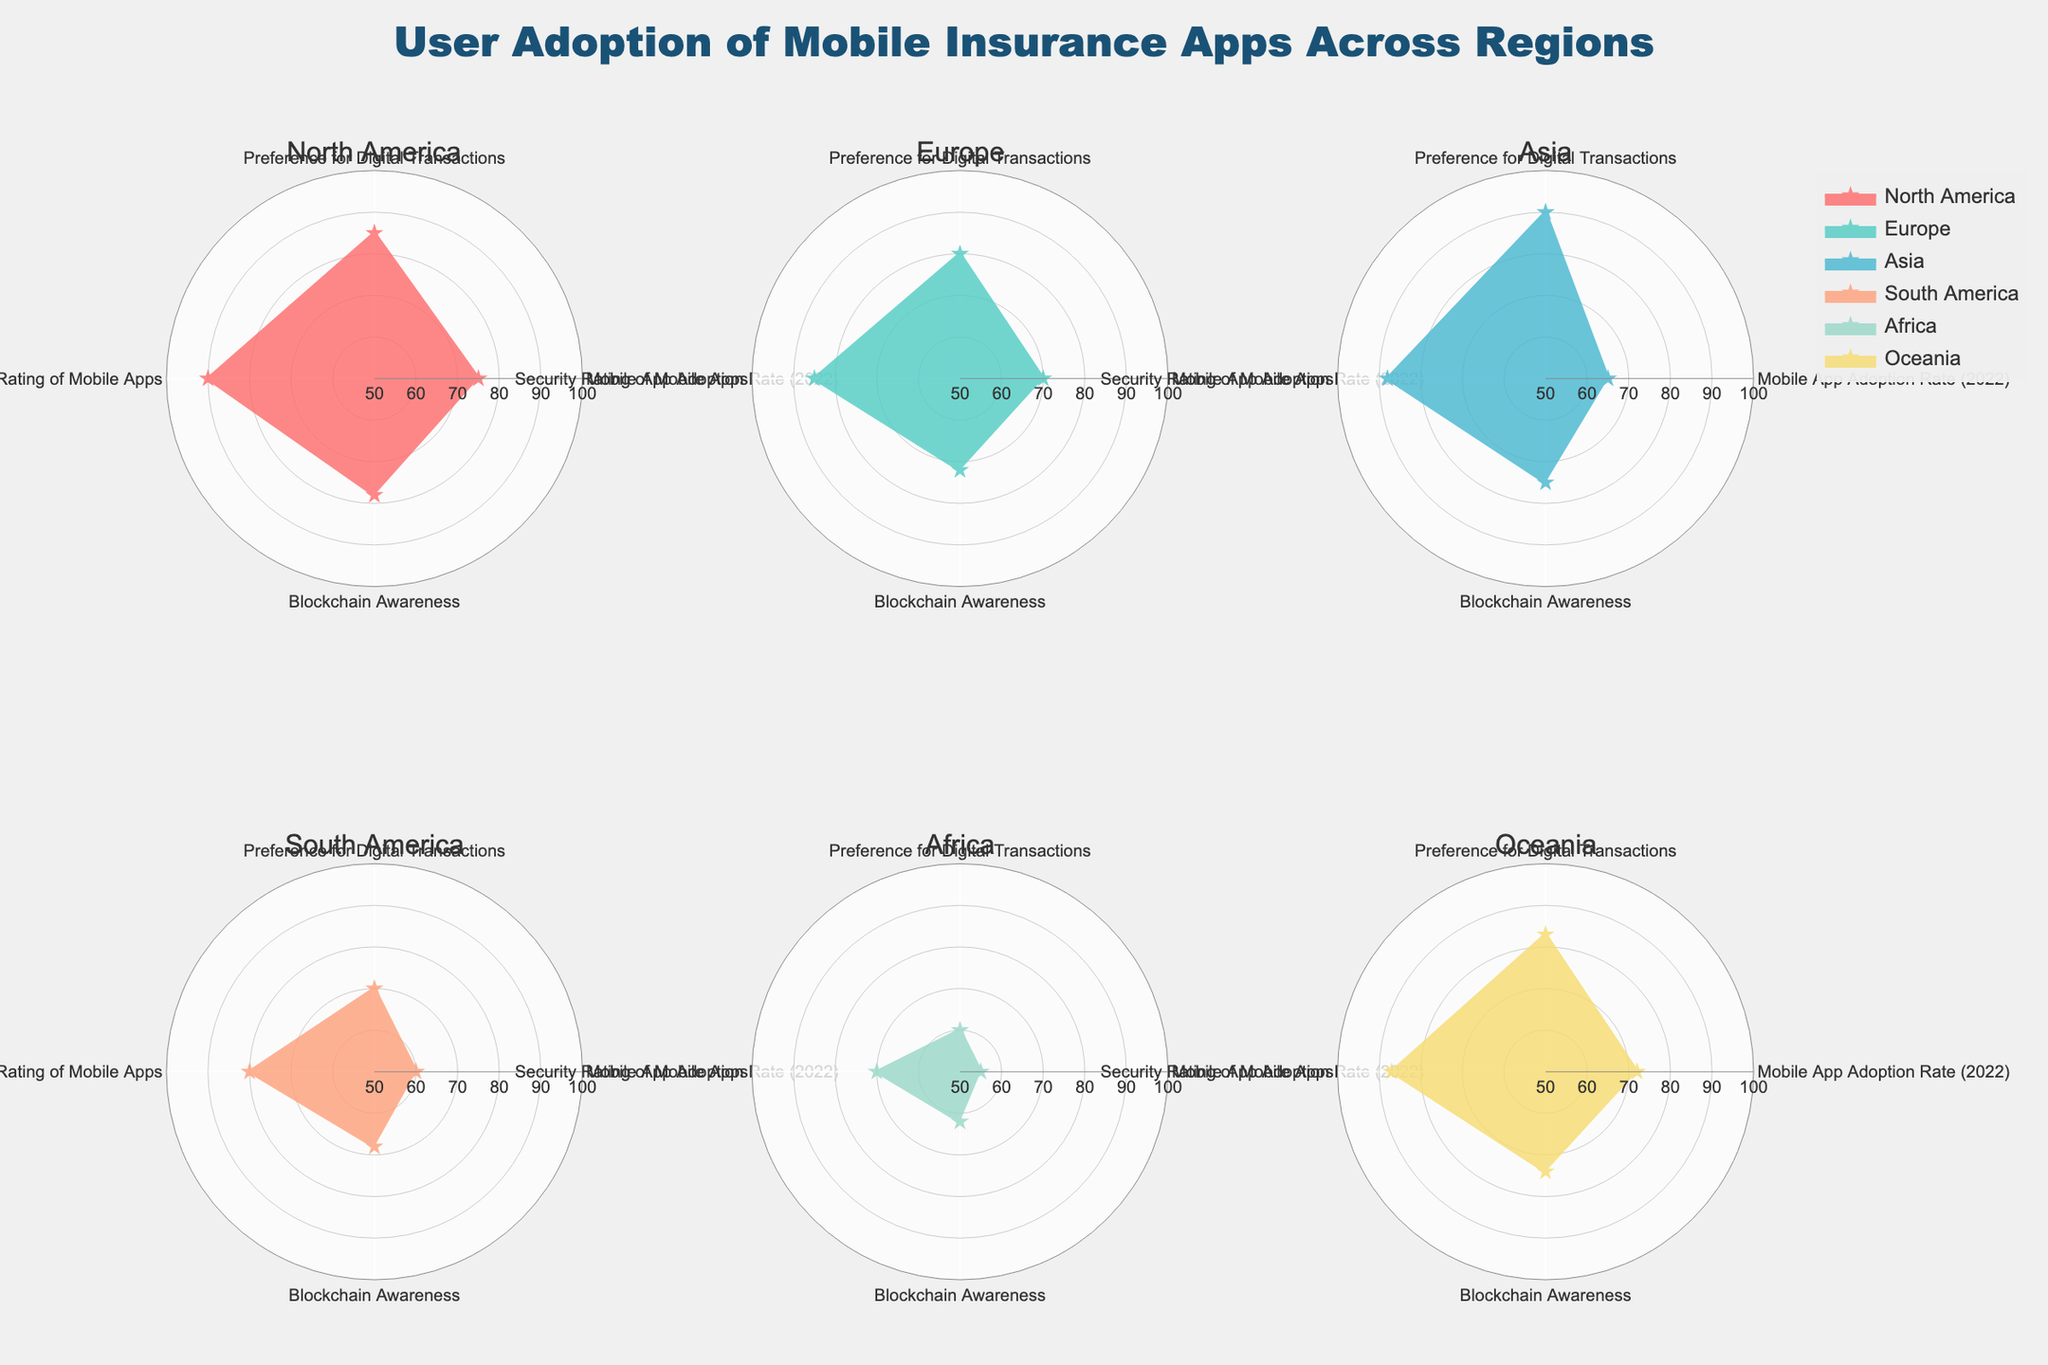Which region has the highest mobile app adoption rate in 2022? By looking at the subplot for each region, we can see that North America, as shown in its respective polar chart, has the highest mobile app adoption rate of 75.
Answer: North America What is the average security rating of mobile apps across all regions? The security ratings for the six regions are 90, 85, 88, 80, 70, and 87. Adding these values and dividing by the number of regions gives (90 + 85 + 88 + 80 + 70 + 87) / 6 = 83.33.
Answer: 83.33 Which region has the lowest awareness of blockchain? The plot for each region shows that Africa has the lowest blockchain awareness with a value of 62.
Answer: Africa Compare the preference for digital transactions between Asia and South America. By comparing the values in their respective polar charts, Asia has a preference value of 90, while South America has 70. Asia has a 20-point higher preference for digital transactions than South America.
Answer: Asia Which region has a higher mobile app adoption rate - Europe or Oceania? Referring to the polar plots, Europe has a mobile app adoption rate of 70 while Oceania has 72. Therefore, Oceania has a slightly higher rate.
Answer: Oceania What is the difference between the highest and lowest security rating of mobile apps among the regions? The highest security rating is in North America with 90 and the lowest is in Africa with 70. The difference is 90 - 70 = 20.
Answer: 20 Which regions have a mobile app adoption rate of above 70? Looking at each polar chart, North America (75), Europe (70), and Oceania (72) have adoption rates above 70. However, Europe is exactly 70, not above it. So only North America and Oceania.
Answer: North America, Oceania How does the blockchain awareness of Asia compare with South America? Asia has a blockchain awareness of 75 while South America has 68. Asia has a higher awareness level by 7 points.
Answer: Asia What is the combined preference for digital transactions of North America and Europe? From the polar charts, North America's preference for digital transactions is 85 and Europe's is 80. Combined, it is 85 + 80 = 165.
Answer: 165 What regions have a security rating equal to or higher than 85? The security ratings equal to or higher than 85 are for North America (90), Europe (85), Asia (88), and Oceania (87).
Answer: North America, Europe, Asia, Oceania 